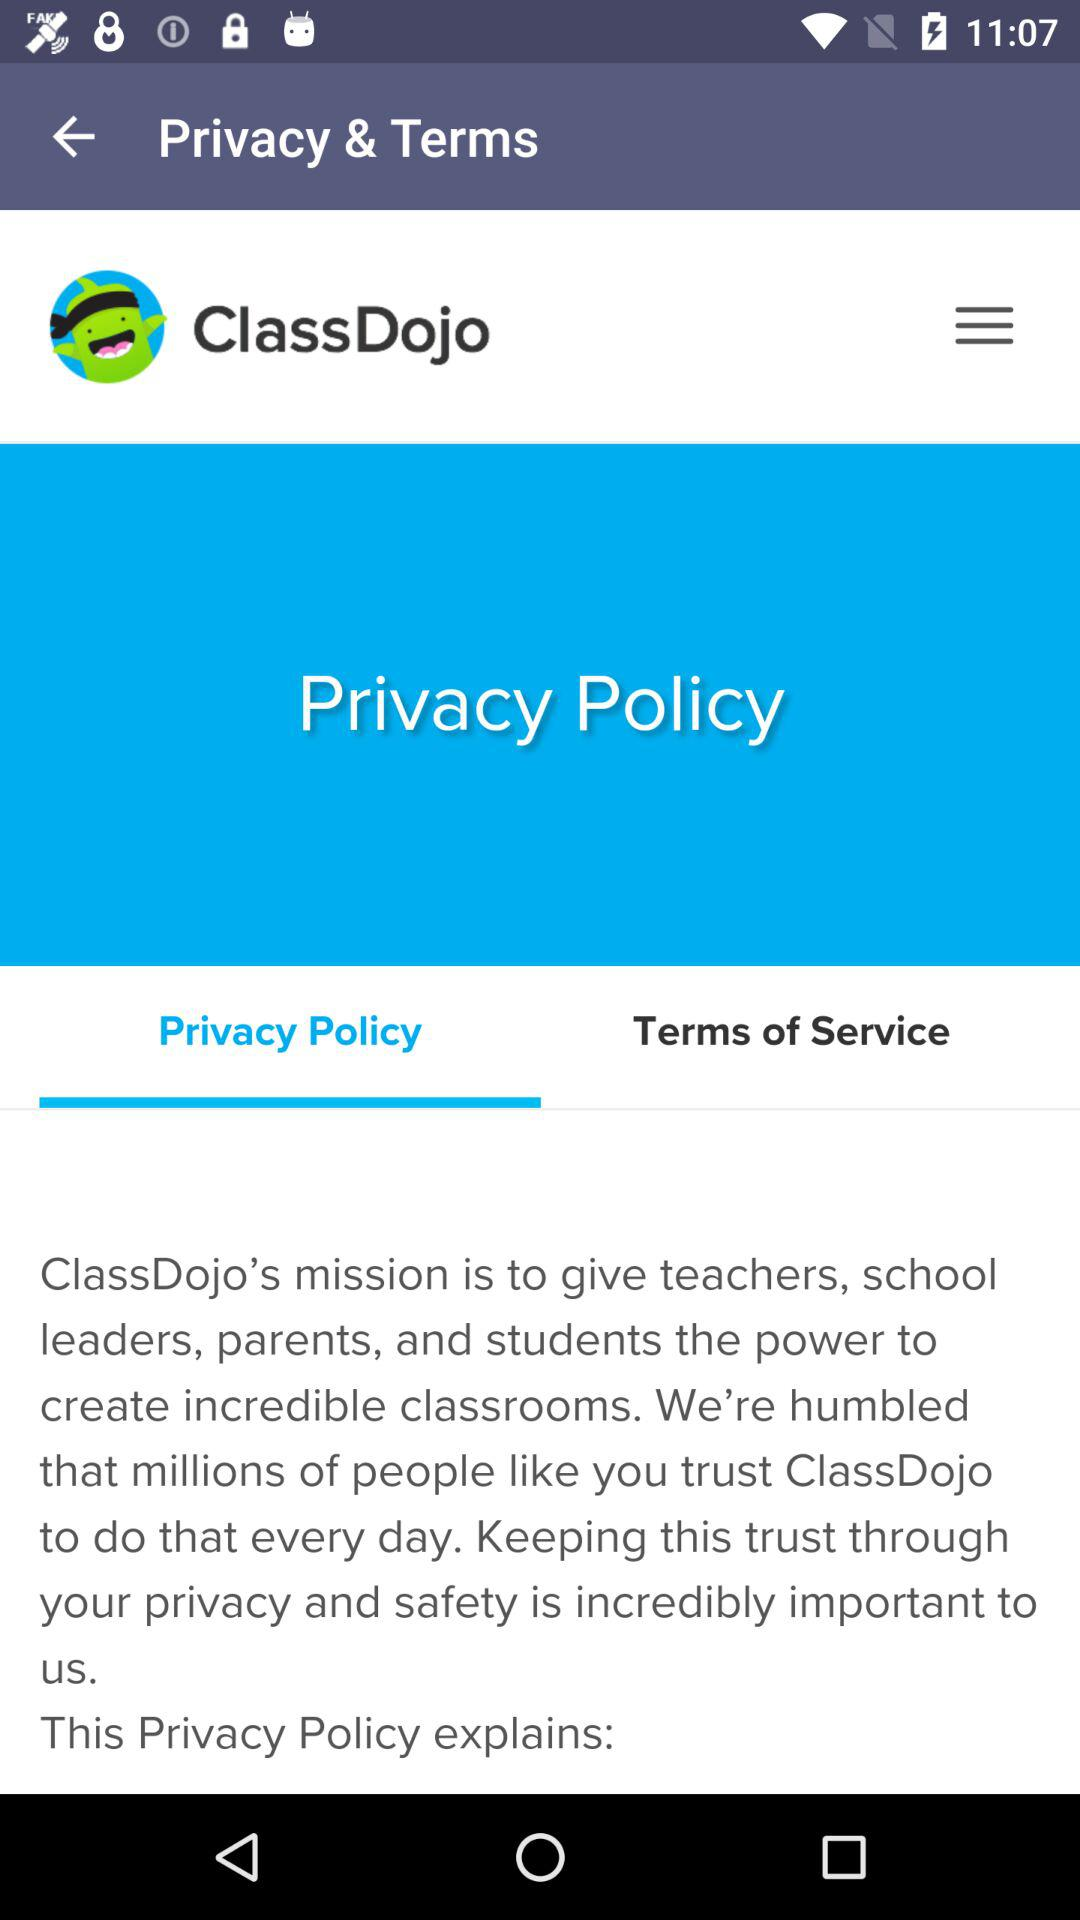Which tab has been selected? The tab that has been selected is "Privacy Policy". 